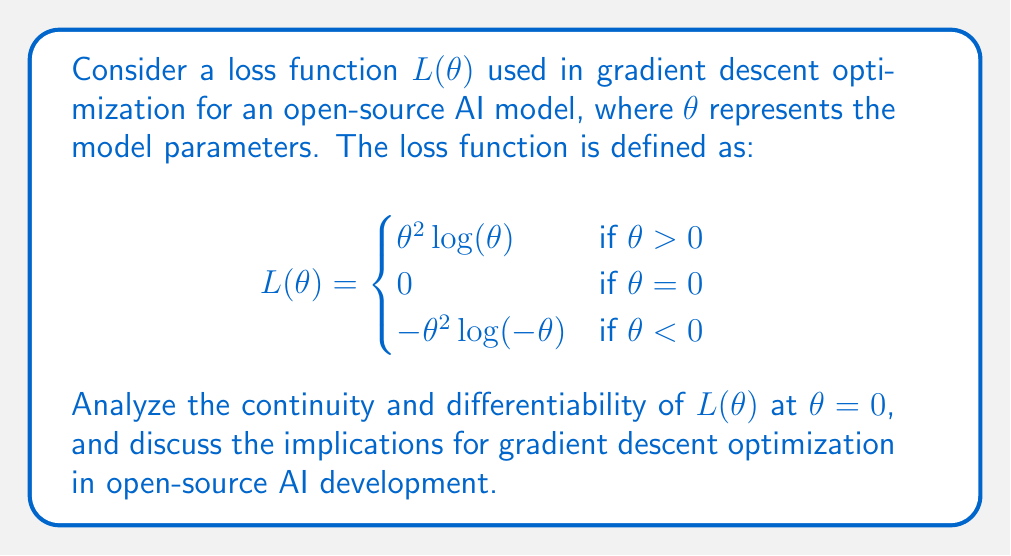Give your solution to this math problem. To analyze the continuity and differentiability of $L(\theta)$ at $\theta = 0$, we need to examine the function's behavior around this point.

1. Continuity:
To check for continuity at $\theta = 0$, we need to verify if the limit of $L(\theta)$ as $\theta$ approaches 0 from both sides exists and equals $L(0)$.

Left-hand limit:
$$\lim_{\theta \to 0^-} L(\theta) = \lim_{\theta \to 0^-} -\theta^2 \log(-\theta) = 0$$

Right-hand limit:
$$\lim_{\theta \to 0^+} L(\theta) = \lim_{\theta \to 0^+} \theta^2 \log(\theta) = 0$$

Since both limits exist and are equal to $L(0) = 0$, the function is continuous at $\theta = 0$.

2. Differentiability:
To check for differentiability at $\theta = 0$, we need to verify if the left-hand and right-hand derivatives exist and are equal.

Left-hand derivative:
$$\lim_{\theta \to 0^-} \frac{L(\theta) - L(0)}{\theta} = \lim_{\theta \to 0^-} \frac{-\theta^2 \log(-\theta) - 0}{\theta} = \lim_{\theta \to 0^-} -\theta \log(-\theta) = 0$$

Right-hand derivative:
$$\lim_{\theta \to 0^+} \frac{L(\theta) - L(0)}{\theta} = \lim_{\theta \to 0^+} \frac{\theta^2 \log(\theta) - 0}{\theta} = \lim_{\theta \to 0^+} \theta \log(\theta) = 0$$

Both one-sided derivatives exist and are equal to 0, so the function is differentiable at $\theta = 0$.

Implications for gradient descent optimization in open-source AI development:

1. Continuity: The continuity of the loss function at $\theta = 0$ ensures that small changes in the model parameters around this point will result in small changes in the loss value. This is crucial for the stability of the optimization process.

2. Differentiability: The differentiability of the loss function at $\theta = 0$ allows for the calculation of gradients at this point, which is essential for gradient descent optimization. This means that the optimization algorithm can navigate through this point without issues.

3. Smoothness: The function is both continuous and differentiable at $\theta = 0$, indicating a smooth transition between the positive and negative regions of $\theta$. This smoothness can help prevent sudden jumps or oscillations in the optimization process.

4. Symmetry: The loss function is symmetric around $\theta = 0$, which can be beneficial in certain AI applications where positive and negative parameter values should be treated equally.

5. Open-source implications: The well-behaved nature of this loss function at $\theta = 0$ makes it suitable for open-source AI development, as it allows for consistent and reliable optimization across different implementations and platforms.
Answer: The loss function $L(\theta)$ is both continuous and differentiable at $\theta = 0$. The left-hand and right-hand limits both equal 0, matching $L(0)$, proving continuity. The left-hand and right-hand derivatives both exist and equal 0, proving differentiability. This smooth behavior at $\theta = 0$ is beneficial for gradient descent optimization in open-source AI development, ensuring stability, consistent gradient calculations, and reliable optimization across different implementations. 